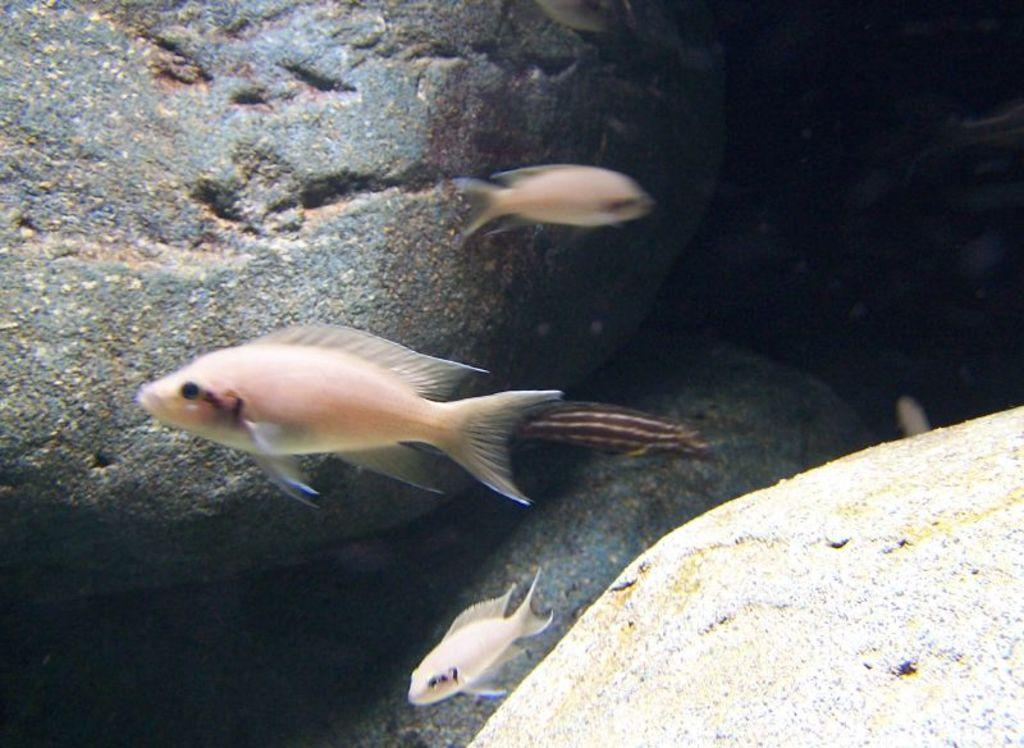What is the main subject in the center of the image? There are fishes in the center of the image. Can you describe anything in the background of the image? There is a stone in the background of the image. What rate does the minister charge for his services in the image? There is no minister or any mention of services or rates in the image. 